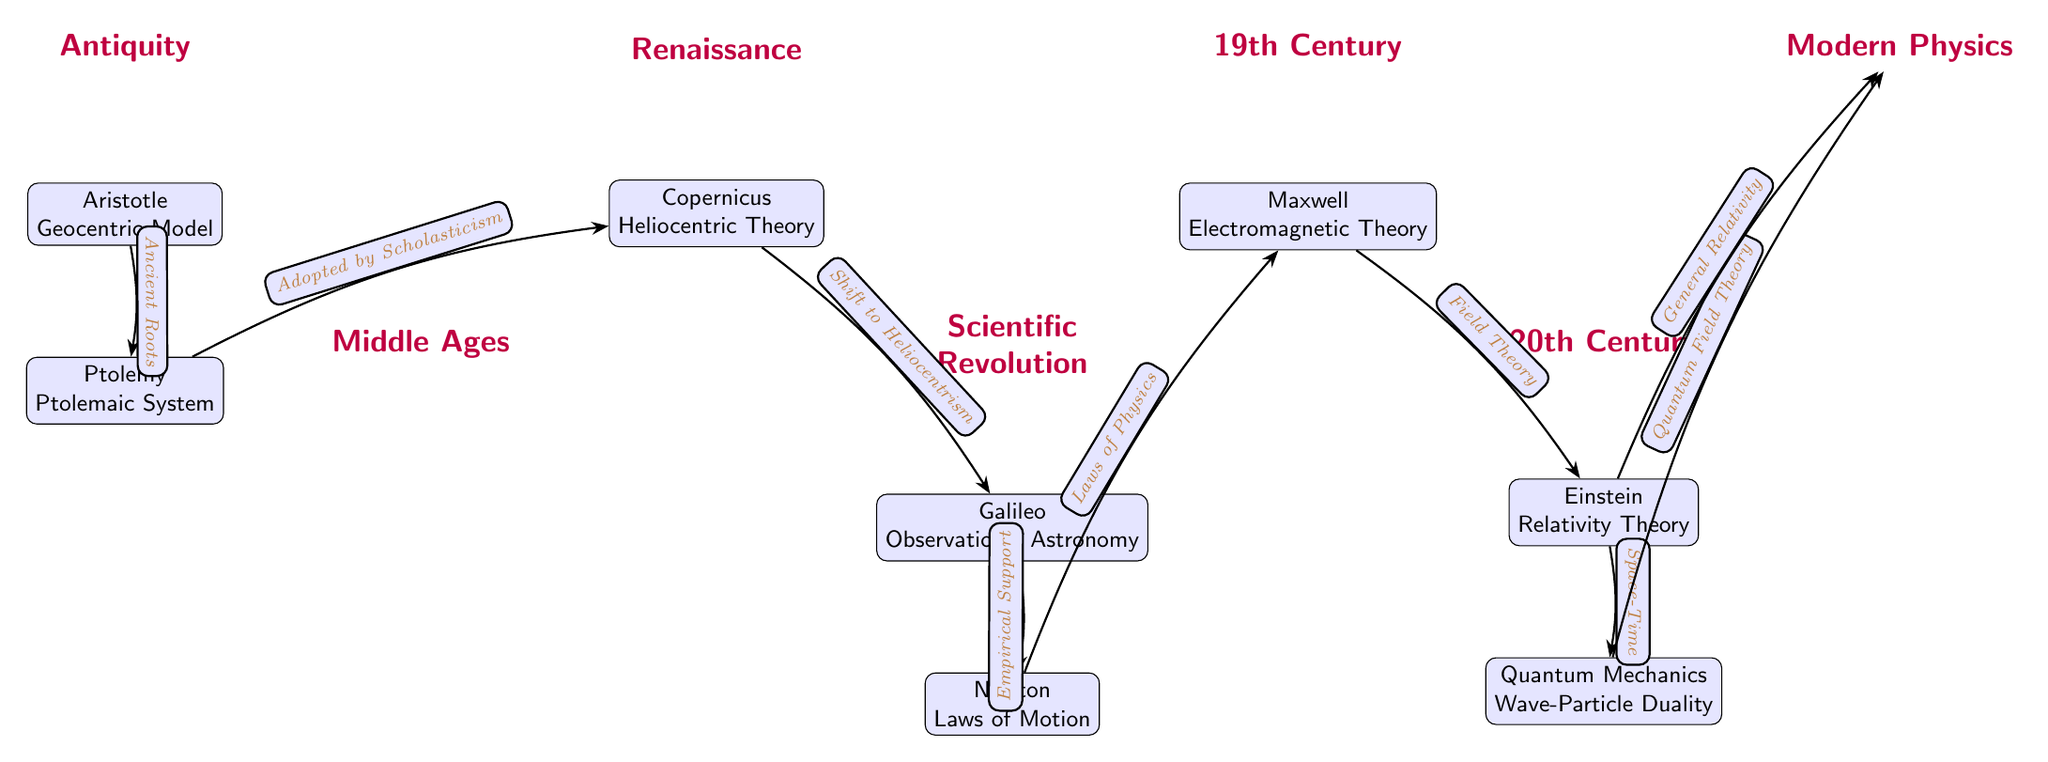What is the first scientific theory depicted in the diagram? The first theory is represented by Aristotle's Geocentric Model, which is located at the top of the diagram under the Antiquity section.
Answer: Aristotle Geocentric Model How many nodes are in the diagram? Counting each time a scientific theory or era is represented results in a total of 8 nodes, which include: Antiquity, Middle Ages, Renaissance, Scientific Revolution, 19th Century, 20th Century, and Modern Physics, along with the theories below each era.
Answer: 8 What follows Galileo in the timeline? After Galileo, represented in the Scientific Revolution section, comes Newton and his Laws of Motion. This sequence can be tracked along the connecting edge leading from Galileo.
Answer: Newton Laws of Motion Which theory is connected to Quantum Mechanics? Quantum Mechanics is directly linked to Modern Physics, as shown by the edge connecting the two nodes in the diagram.
Answer: Modern Physics What does the edge from Copernicus to Galileo indicate? The edge indicates a shift to heliocentrism, which reflects the historical progression of ideas in the scientific method at that time. This connection indicates the transition in astronomical theories from geocentrism to heliocentrism.
Answer: Shift to Heliocentrism Which scientific theory showcases the concept of Space-Time? The theory of Relativity, formulated by Einstein, is the one that introduces the concept of Space-Time, as indicated by the edge from Einstein to Quantum Mechanics.
Answer: Relativity Theory Which theory represents the culmination of Quantum Field Theory in the timeline? Modern Physics represents the culmination of Quantum Field Theory, as indicated by the edge connecting the two nodes.
Answer: Modern Physics What is the historical significance of Maxwell's Electromagnetic Theory in the diagram? Maxwell's Electromagnetic Theory represents a pivotal moment in the 19th Century that connected Newton's Laws of Motion to Einstein's theories, indicating the advancement of understanding physical laws.
Answer: Field Theory 